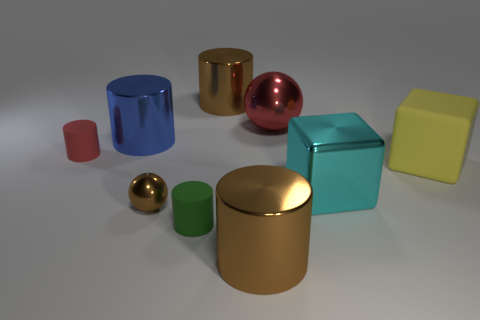Subtract all green cylinders. How many cylinders are left? 4 Subtract all brown spheres. How many spheres are left? 1 Subtract 2 balls. How many balls are left? 0 Subtract all blocks. How many objects are left? 7 Add 2 metal cubes. How many metal cubes are left? 3 Add 6 small green matte things. How many small green matte things exist? 7 Subtract 1 red cylinders. How many objects are left? 8 Subtract all blue spheres. Subtract all brown blocks. How many spheres are left? 2 Subtract all brown cylinders. How many purple cubes are left? 0 Subtract all small cylinders. Subtract all small red matte things. How many objects are left? 6 